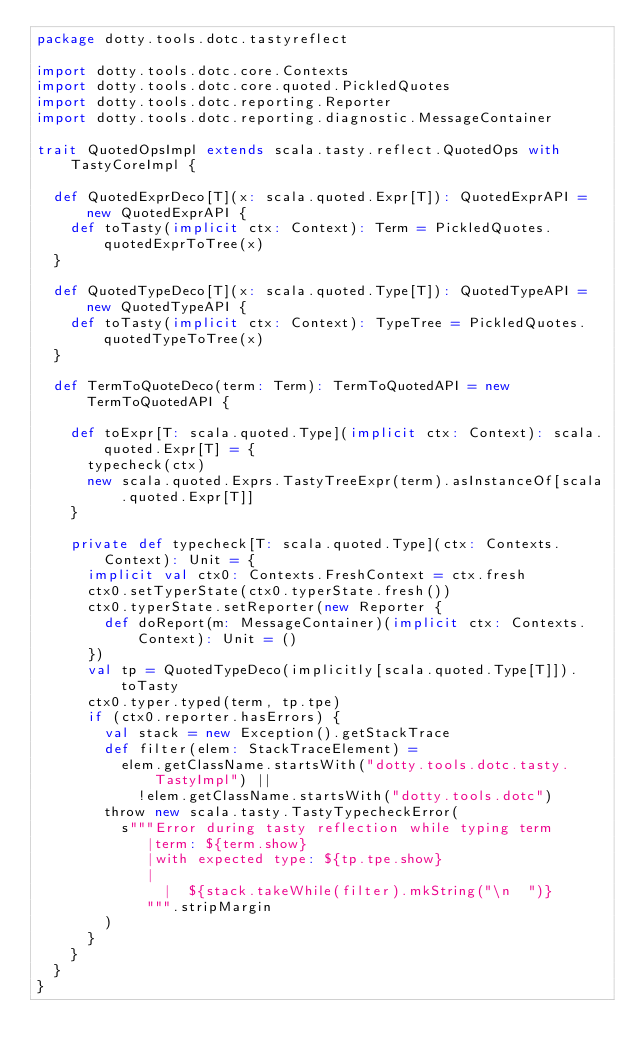<code> <loc_0><loc_0><loc_500><loc_500><_Scala_>package dotty.tools.dotc.tastyreflect

import dotty.tools.dotc.core.Contexts
import dotty.tools.dotc.core.quoted.PickledQuotes
import dotty.tools.dotc.reporting.Reporter
import dotty.tools.dotc.reporting.diagnostic.MessageContainer

trait QuotedOpsImpl extends scala.tasty.reflect.QuotedOps with TastyCoreImpl {

  def QuotedExprDeco[T](x: scala.quoted.Expr[T]): QuotedExprAPI = new QuotedExprAPI {
    def toTasty(implicit ctx: Context): Term = PickledQuotes.quotedExprToTree(x)
  }

  def QuotedTypeDeco[T](x: scala.quoted.Type[T]): QuotedTypeAPI = new QuotedTypeAPI {
    def toTasty(implicit ctx: Context): TypeTree = PickledQuotes.quotedTypeToTree(x)
  }

  def TermToQuoteDeco(term: Term): TermToQuotedAPI = new TermToQuotedAPI {

    def toExpr[T: scala.quoted.Type](implicit ctx: Context): scala.quoted.Expr[T] = {
      typecheck(ctx)
      new scala.quoted.Exprs.TastyTreeExpr(term).asInstanceOf[scala.quoted.Expr[T]]
    }

    private def typecheck[T: scala.quoted.Type](ctx: Contexts.Context): Unit = {
      implicit val ctx0: Contexts.FreshContext = ctx.fresh
      ctx0.setTyperState(ctx0.typerState.fresh())
      ctx0.typerState.setReporter(new Reporter {
        def doReport(m: MessageContainer)(implicit ctx: Contexts.Context): Unit = ()
      })
      val tp = QuotedTypeDeco(implicitly[scala.quoted.Type[T]]).toTasty
      ctx0.typer.typed(term, tp.tpe)
      if (ctx0.reporter.hasErrors) {
        val stack = new Exception().getStackTrace
        def filter(elem: StackTraceElement) =
          elem.getClassName.startsWith("dotty.tools.dotc.tasty.TastyImpl") ||
            !elem.getClassName.startsWith("dotty.tools.dotc")
        throw new scala.tasty.TastyTypecheckError(
          s"""Error during tasty reflection while typing term
             |term: ${term.show}
             |with expected type: ${tp.tpe.show}
             |
               |  ${stack.takeWhile(filter).mkString("\n  ")}
             """.stripMargin
        )
      }
    }
  }
}
</code> 